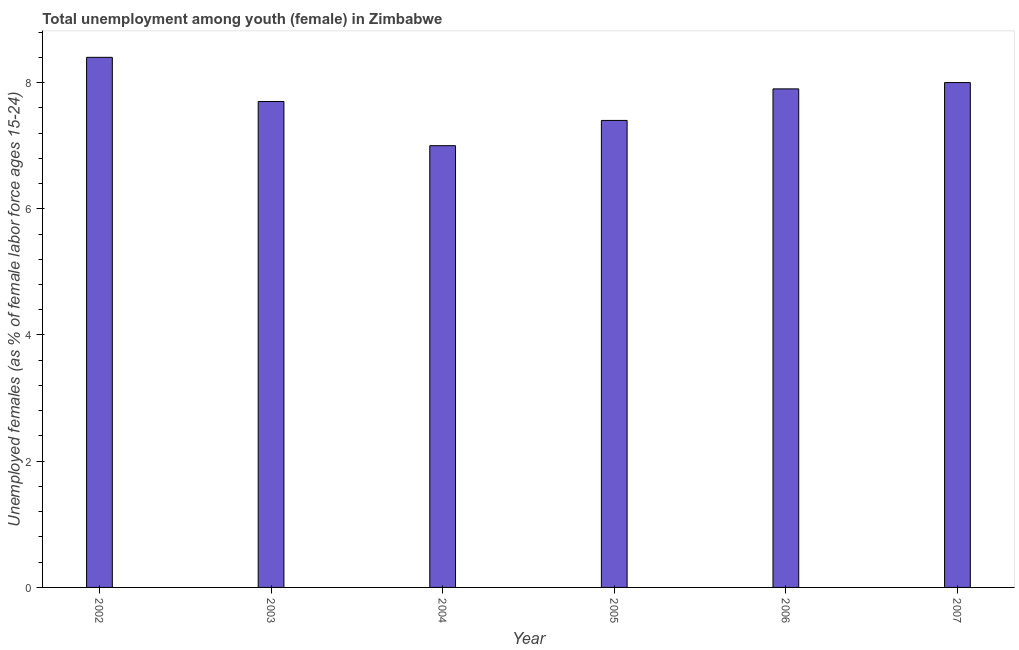Does the graph contain any zero values?
Ensure brevity in your answer.  No. What is the title of the graph?
Provide a short and direct response. Total unemployment among youth (female) in Zimbabwe. What is the label or title of the Y-axis?
Offer a terse response. Unemployed females (as % of female labor force ages 15-24). What is the unemployed female youth population in 2002?
Your response must be concise. 8.4. Across all years, what is the maximum unemployed female youth population?
Offer a terse response. 8.4. In which year was the unemployed female youth population maximum?
Provide a short and direct response. 2002. What is the sum of the unemployed female youth population?
Offer a terse response. 46.4. What is the difference between the unemployed female youth population in 2003 and 2004?
Your answer should be very brief. 0.7. What is the average unemployed female youth population per year?
Give a very brief answer. 7.73. What is the median unemployed female youth population?
Provide a short and direct response. 7.8. What is the ratio of the unemployed female youth population in 2002 to that in 2005?
Give a very brief answer. 1.14. Is the unemployed female youth population in 2003 less than that in 2007?
Your answer should be very brief. Yes. Is the sum of the unemployed female youth population in 2004 and 2006 greater than the maximum unemployed female youth population across all years?
Provide a short and direct response. Yes. In how many years, is the unemployed female youth population greater than the average unemployed female youth population taken over all years?
Give a very brief answer. 3. How many bars are there?
Keep it short and to the point. 6. Are all the bars in the graph horizontal?
Give a very brief answer. No. What is the difference between two consecutive major ticks on the Y-axis?
Give a very brief answer. 2. Are the values on the major ticks of Y-axis written in scientific E-notation?
Offer a terse response. No. What is the Unemployed females (as % of female labor force ages 15-24) of 2002?
Make the answer very short. 8.4. What is the Unemployed females (as % of female labor force ages 15-24) of 2003?
Provide a succinct answer. 7.7. What is the Unemployed females (as % of female labor force ages 15-24) in 2004?
Offer a terse response. 7. What is the Unemployed females (as % of female labor force ages 15-24) of 2005?
Make the answer very short. 7.4. What is the Unemployed females (as % of female labor force ages 15-24) in 2006?
Your response must be concise. 7.9. What is the difference between the Unemployed females (as % of female labor force ages 15-24) in 2002 and 2003?
Offer a very short reply. 0.7. What is the difference between the Unemployed females (as % of female labor force ages 15-24) in 2002 and 2004?
Make the answer very short. 1.4. What is the difference between the Unemployed females (as % of female labor force ages 15-24) in 2002 and 2005?
Your answer should be very brief. 1. What is the difference between the Unemployed females (as % of female labor force ages 15-24) in 2002 and 2006?
Your response must be concise. 0.5. What is the difference between the Unemployed females (as % of female labor force ages 15-24) in 2006 and 2007?
Provide a short and direct response. -0.1. What is the ratio of the Unemployed females (as % of female labor force ages 15-24) in 2002 to that in 2003?
Provide a succinct answer. 1.09. What is the ratio of the Unemployed females (as % of female labor force ages 15-24) in 2002 to that in 2004?
Provide a short and direct response. 1.2. What is the ratio of the Unemployed females (as % of female labor force ages 15-24) in 2002 to that in 2005?
Your answer should be very brief. 1.14. What is the ratio of the Unemployed females (as % of female labor force ages 15-24) in 2002 to that in 2006?
Ensure brevity in your answer.  1.06. What is the ratio of the Unemployed females (as % of female labor force ages 15-24) in 2003 to that in 2004?
Ensure brevity in your answer.  1.1. What is the ratio of the Unemployed females (as % of female labor force ages 15-24) in 2003 to that in 2005?
Keep it short and to the point. 1.04. What is the ratio of the Unemployed females (as % of female labor force ages 15-24) in 2004 to that in 2005?
Keep it short and to the point. 0.95. What is the ratio of the Unemployed females (as % of female labor force ages 15-24) in 2004 to that in 2006?
Keep it short and to the point. 0.89. What is the ratio of the Unemployed females (as % of female labor force ages 15-24) in 2005 to that in 2006?
Offer a terse response. 0.94. What is the ratio of the Unemployed females (as % of female labor force ages 15-24) in 2005 to that in 2007?
Offer a very short reply. 0.93. What is the ratio of the Unemployed females (as % of female labor force ages 15-24) in 2006 to that in 2007?
Offer a very short reply. 0.99. 